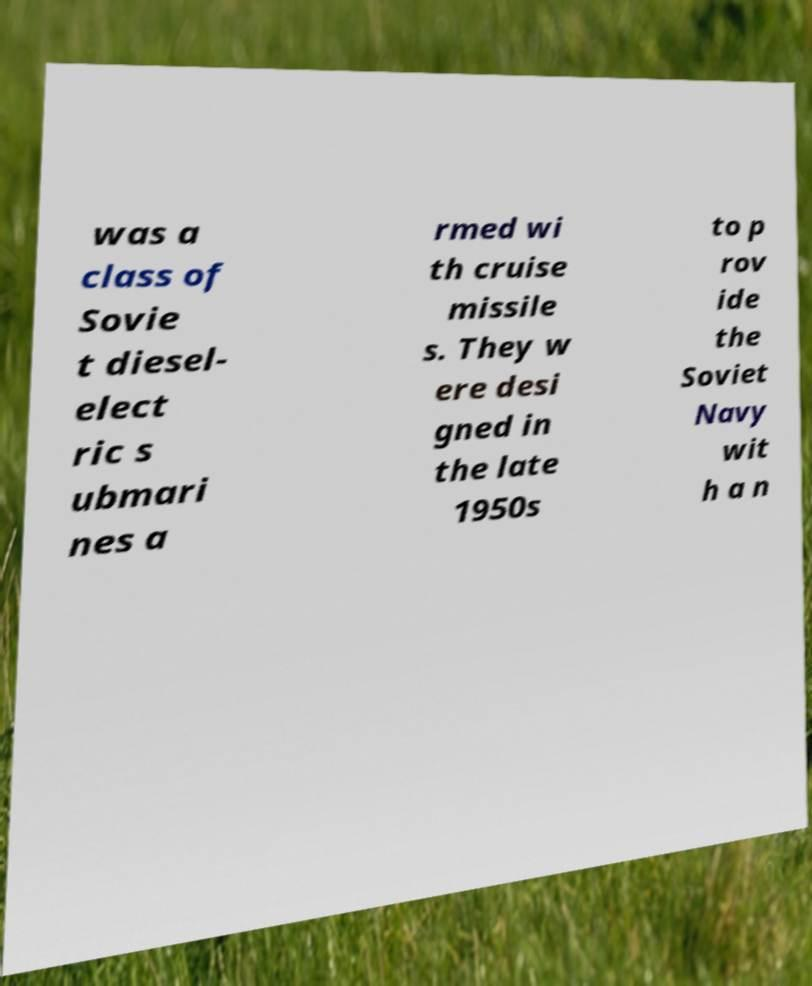There's text embedded in this image that I need extracted. Can you transcribe it verbatim? was a class of Sovie t diesel- elect ric s ubmari nes a rmed wi th cruise missile s. They w ere desi gned in the late 1950s to p rov ide the Soviet Navy wit h a n 